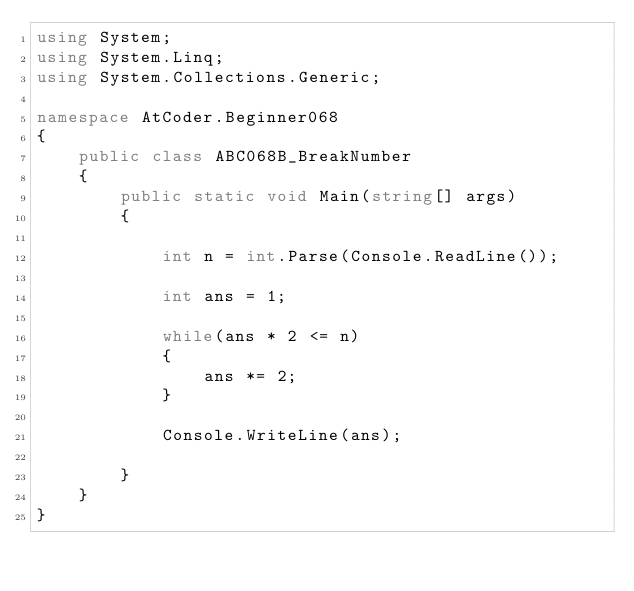Convert code to text. <code><loc_0><loc_0><loc_500><loc_500><_C#_>using System;
using System.Linq;
using System.Collections.Generic;

namespace AtCoder.Beginner068
{
    public class ABC068B_BreakNumber
    {
        public static void Main(string[] args)
        {

            int n = int.Parse(Console.ReadLine());

            int ans = 1;

            while(ans * 2 <= n)
            {
                ans *= 2;
            }

            Console.WriteLine(ans);

        }
    }
}</code> 